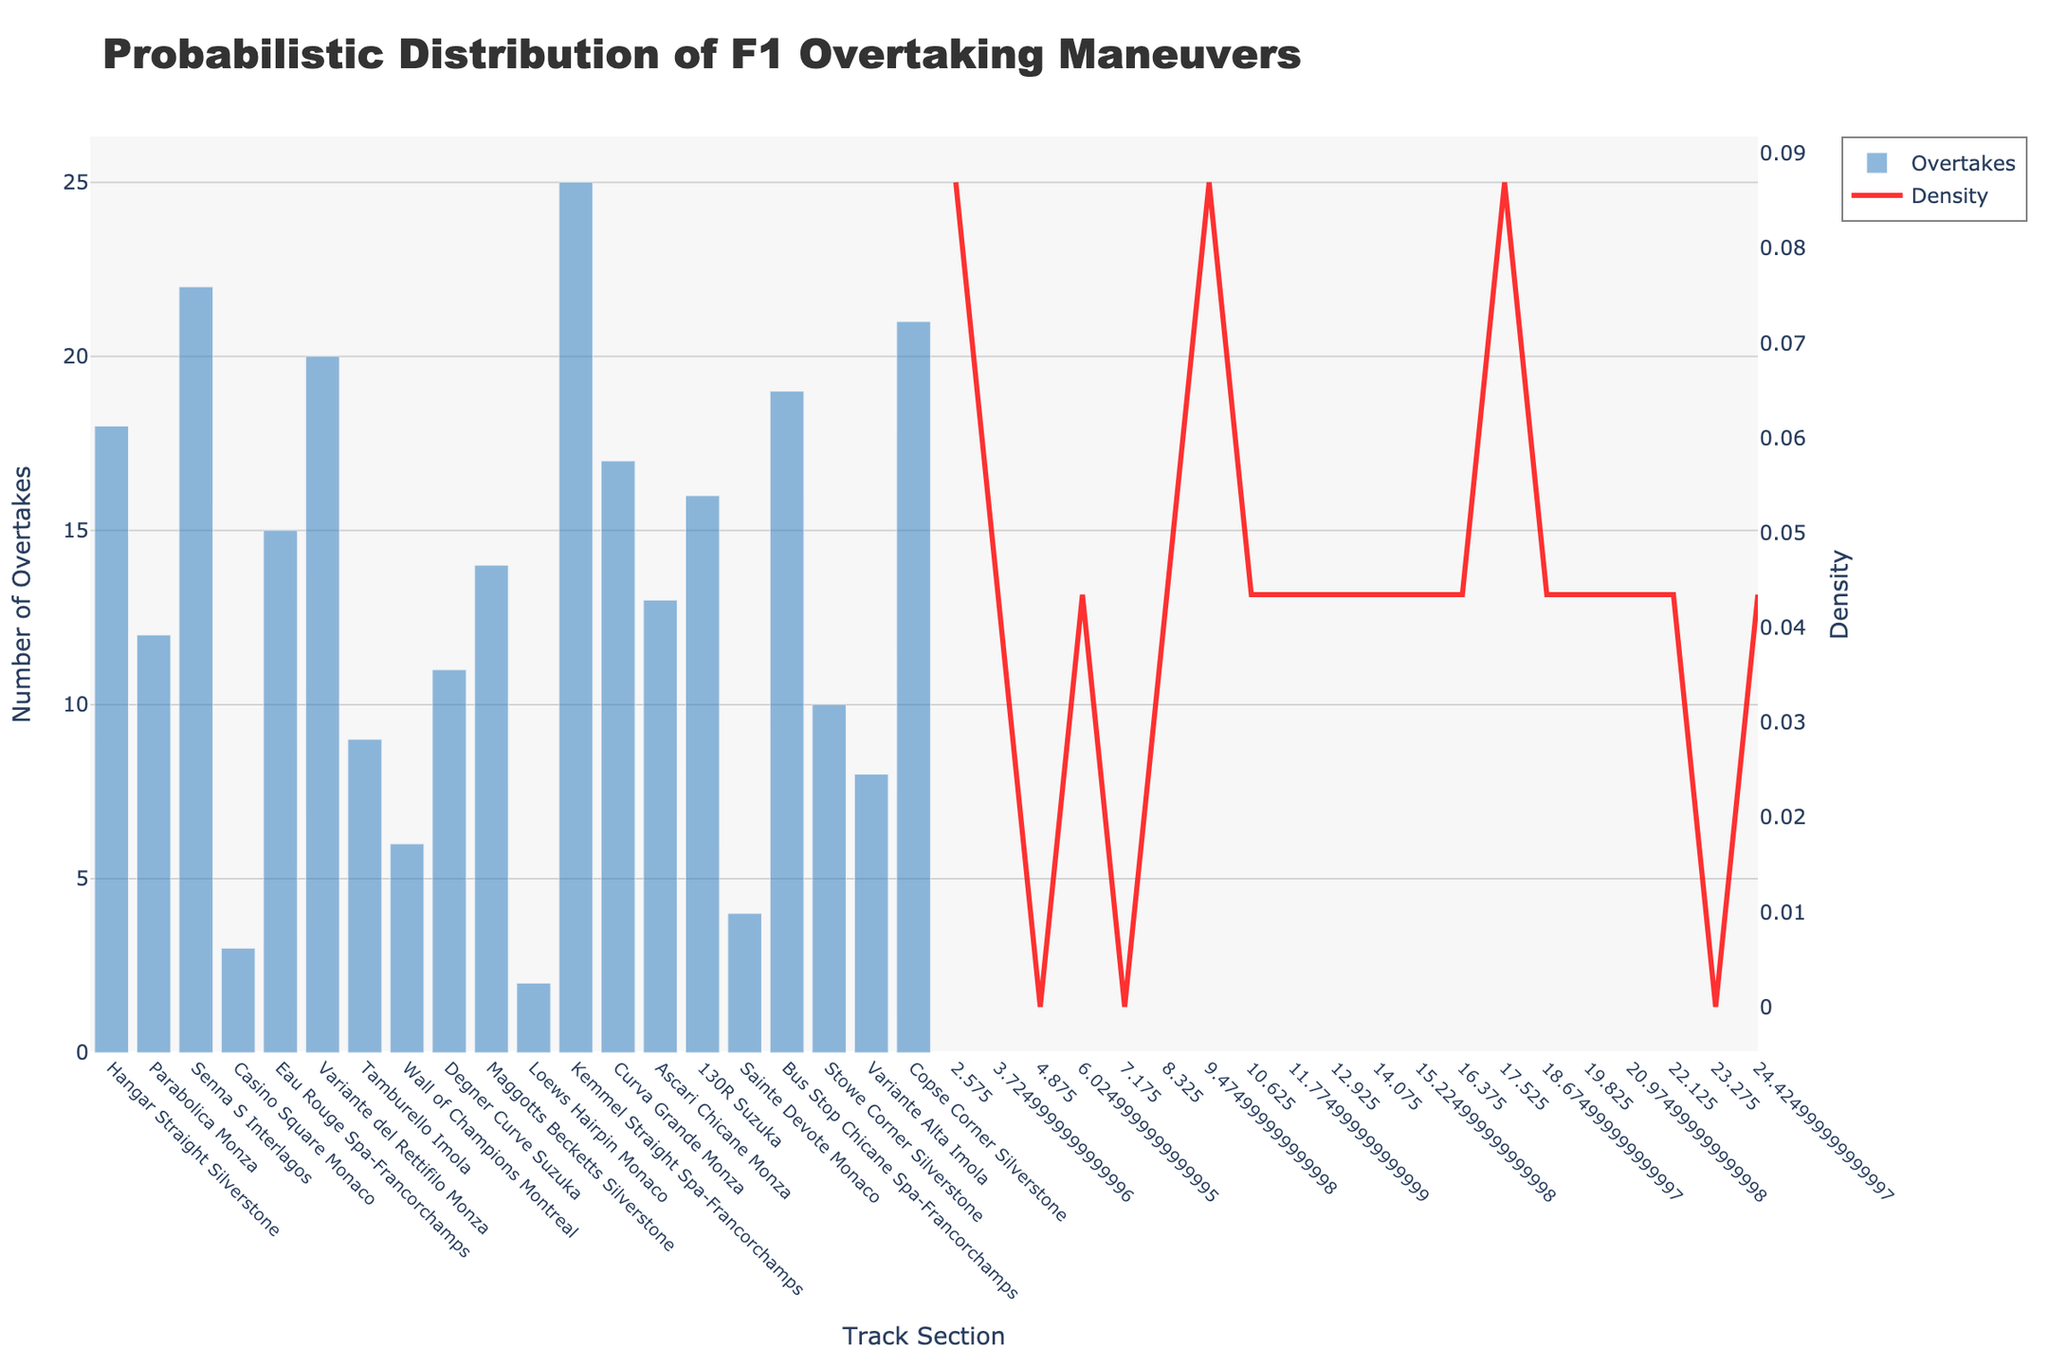What is the title of the plot? The title of the plot is written at the top of the figure. It reads "Probabilistic Distribution of F1 Overtaking Maneuvers".
Answer: Probabilistic Distribution of F1 Overtaking Maneuvers How many track sections are shown on the x-axis? Count each unique label along the x-axis corresponding to track sections where overtakes are measured.
Answer: 20 Which track section has the highest number of overtakes? Identify the bar that reaches the highest on the y-axis, that corresponds to the track section label below it on the x-axis. The highest bar corresponds to the Kemmel Straight at Spa-Francorchamps with 25 overtakes.
Answer: Kemmel Straight Spa-Francorchamps What is the density value at 'Curva Grande Monza' compared to 'Casino Square Monaco'? Look at the length of the red (density) curve at both points. 'Curva Grande Monza' should have a higher density value than 'Casino Square Monaco'.
Answer: Higher What is the average number of overtakes across all track sections? Sum up all y-values (number of overtakes) and divide by the number of track sections (20). (18 + 12 + 22 + 3 + 15 + 20 + 9 + 6 + 11 + 14 + 2 + 25 + 17 + 13 + 16 + 4 + 19 + 10 + 8 + 21) = 255, and 255 / 20 = 12.75
Answer: 12.75 Which track section has the lowest number of overtakes and how many overtakes are there? Identify the shortest bar along the y-axis and check the corresponding x-axis label and the y-value. The Loews Hairpin in Monaco has the lowest count with 2 overtakes.
Answer: Loews Hairpin Monaco, 2 What is the range of overtakes observed in the plot? Subtract the lowest number of overtakes (2 at Loews Hairpin Monaco) from the highest number of overtakes (25 at Kemmel Straight Spa-Francorchamps). 25 - 2 = 23.
Answer: 23 Which track sections have overtakes greater than 20? Identify bars that exceed the 20 overtakes mark on the y-axis: 'Senna S Interlagos' (22), 'Kemmel Straight Spa-Francorchamps' (25), and 'Copse Corner Silverstone' (21).
Answer: Senna S Interlagos, Kemmel Straight Spa-Francorchamps, Copse Corner Silverstone What is the density at the maximum number of overtakes? Locate the peak of the KDE curve (the red line) over the bar with the maximal number of overtakes which is 25 at Kemmel Straight. From the placement, estimate the KDE value which is around 0.1.
Answer: Approximately 0.1 How does the number of overtakes at '130R Suzuka' compare to 'Wall of Champions Montreal'? Compare the heights of the bars for these two sections. '130R Suzuka' has more overtakes (16) compared to 'Wall of Champions Montreal' (6).
Answer: 130R Suzuka has more 